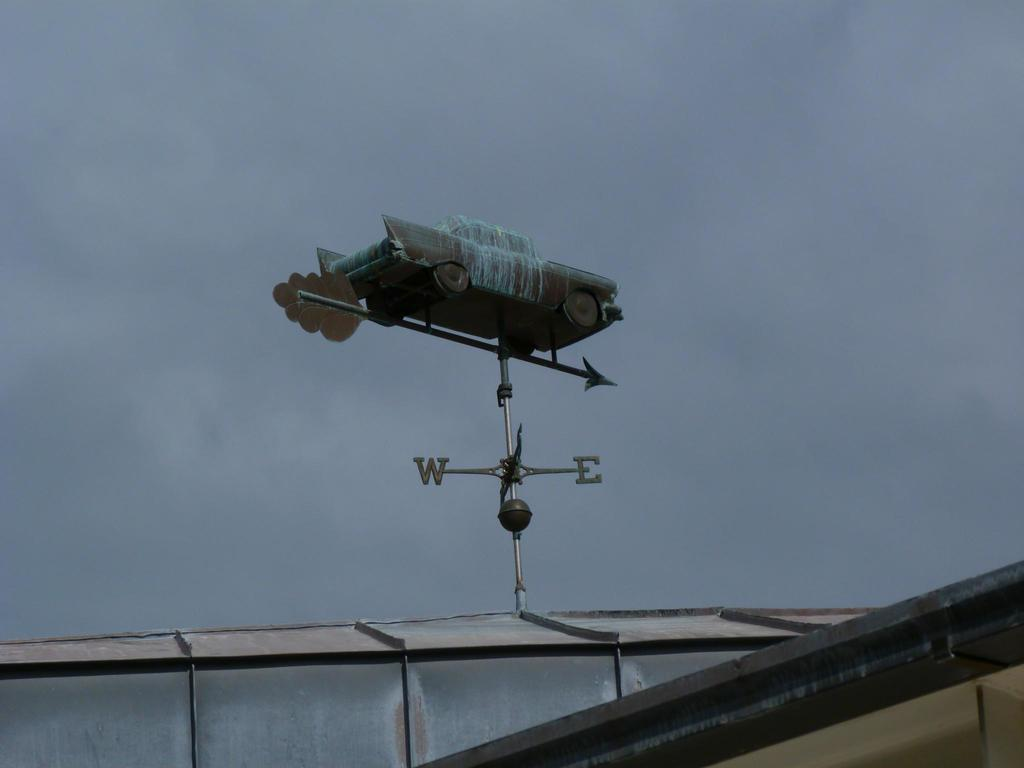<image>
Offer a succinct explanation of the picture presented. A weather vein sits on top of a house pointing towards East. 